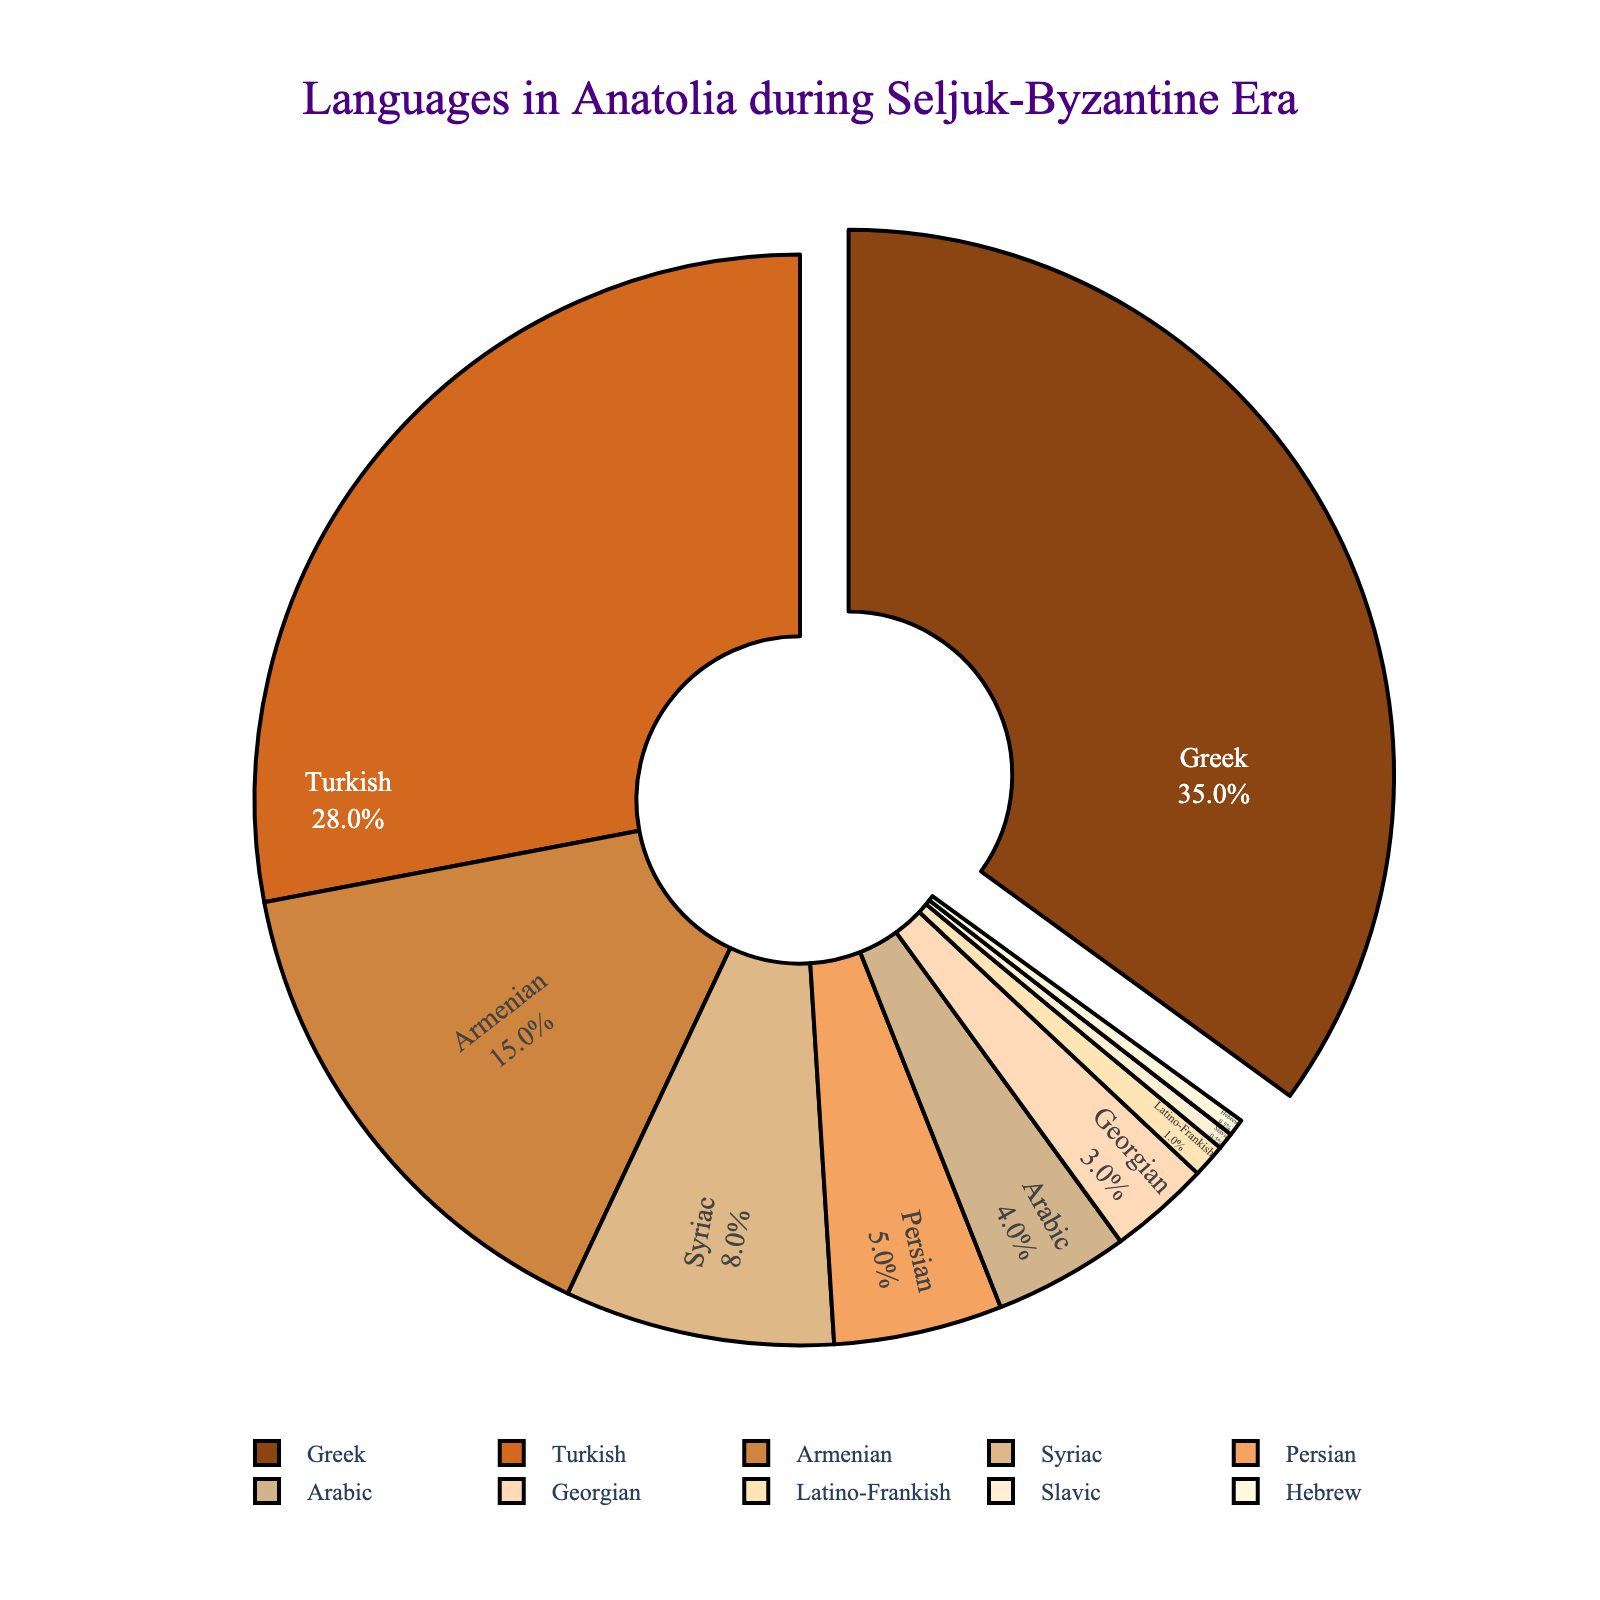What percentage of the population spoke Greek and Turkish combined? To find the combined percentage of Greek and Turkish speakers, sum the individual percentages: Greek (35%) + Turkish (28%).
Answer: 63% Which language has the highest percentage, and what is that percentage? The language with the highest percentage is Greek with 35%. This information is clearly depicted by the largest segment in the pie chart labeled "Greek."
Answer: Greek, 35% Which languages have a larger combined percentage than Turkish? To determine this, we look at the pie chart and sum the percentages of languages individually and then in combinations to identify those higher than Turkish (28%). Greek and Greek + Armenian (35% + 15% = 50%) are higher.
Answer: Greek How much larger is the percentage of Greek speakers compared to Armenian speakers? Subtract the Armenian percentage from the Greek percentage: 35% - 15% = 20%.
Answer: 20% Which language has the smallest percentage, and what is that percentage? The smallest percentage languages are Slavic and Hebrew, each with 0.5%. This is indicated by the smallest segments in the pie chart.
Answer: Slavic and Hebrew, 0.5% What percentage do the spoken languages other than Greek and Turkish represent? Add the percentages of all languages except Greek and Turkish: Armenian (15%) + Syriac (8%) + Persian (5%) + Arabic (4%) + Georgian (3%) + Latino-Frankish (1%) + Slavic (0.5%) + Hebrew (0.5%) = 37%.
Answer: 37% Which language groups have a combined representation of exactly 12%? The only combination that yields 12% exactly is Georgian (3%) + Latino-Frankish (1%) + Slavic (0.5%) + Hebrew (0.5%) + Arabic (4%) + Persian (5%) - which together sum up to 12%.
Answer: Georgian, Latino-Frankish, Slavic, Hebrew, Arabic, Persian What is the visual color assigned to the largest segment in the pie chart? The largest segment, labeled Greek, is visually depicted in a dark brown hue. This can be concluded by visual inspection of the color contrast.
Answer: Dark brown Is the percentage of Turkish speakers more than twice that of Persian speakers? The percentage of Turkish speakers is 28% whereas Persian speakers represent 5%. 28% is more than twice 5% (2x5% = 10%).
Answer: Yes 